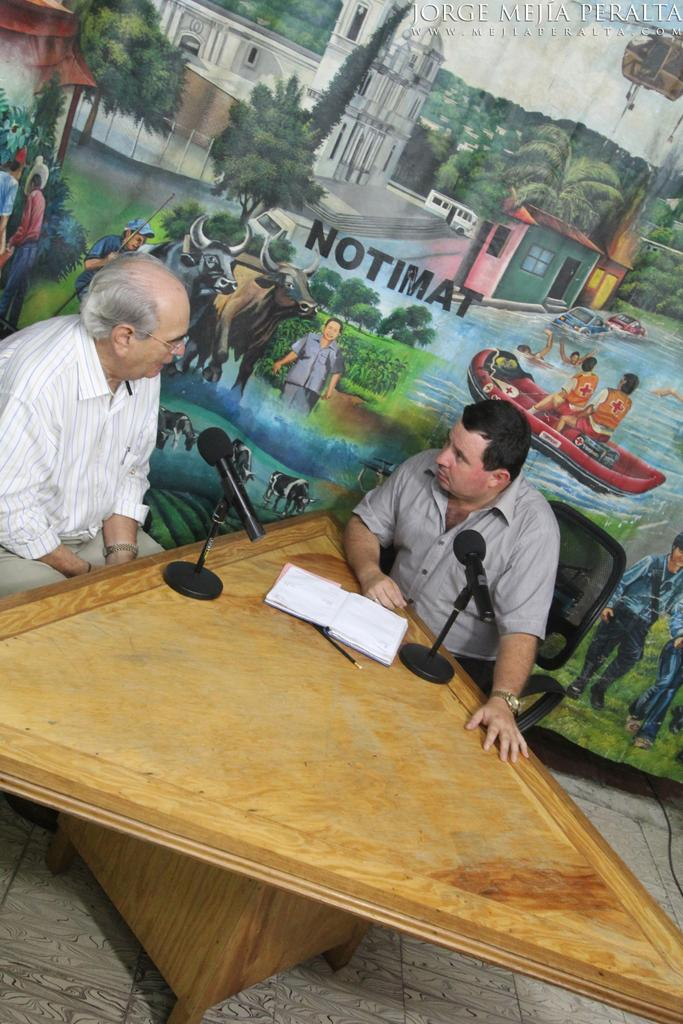How many people are in the image? There are two men in the image. What are the men doing in the image? The men are sitting on chairs. What objects can be seen on the table in the image? There is a microphone, a book, and a pen on the table. What can be seen in the background of the image? There is a painting in the background of the image. What type of bells can be heard ringing in the image? There are no bells present in the image, and therefore no sound can be heard. Can you tell me where the nest is located in the image? There is no nest present in the image. 